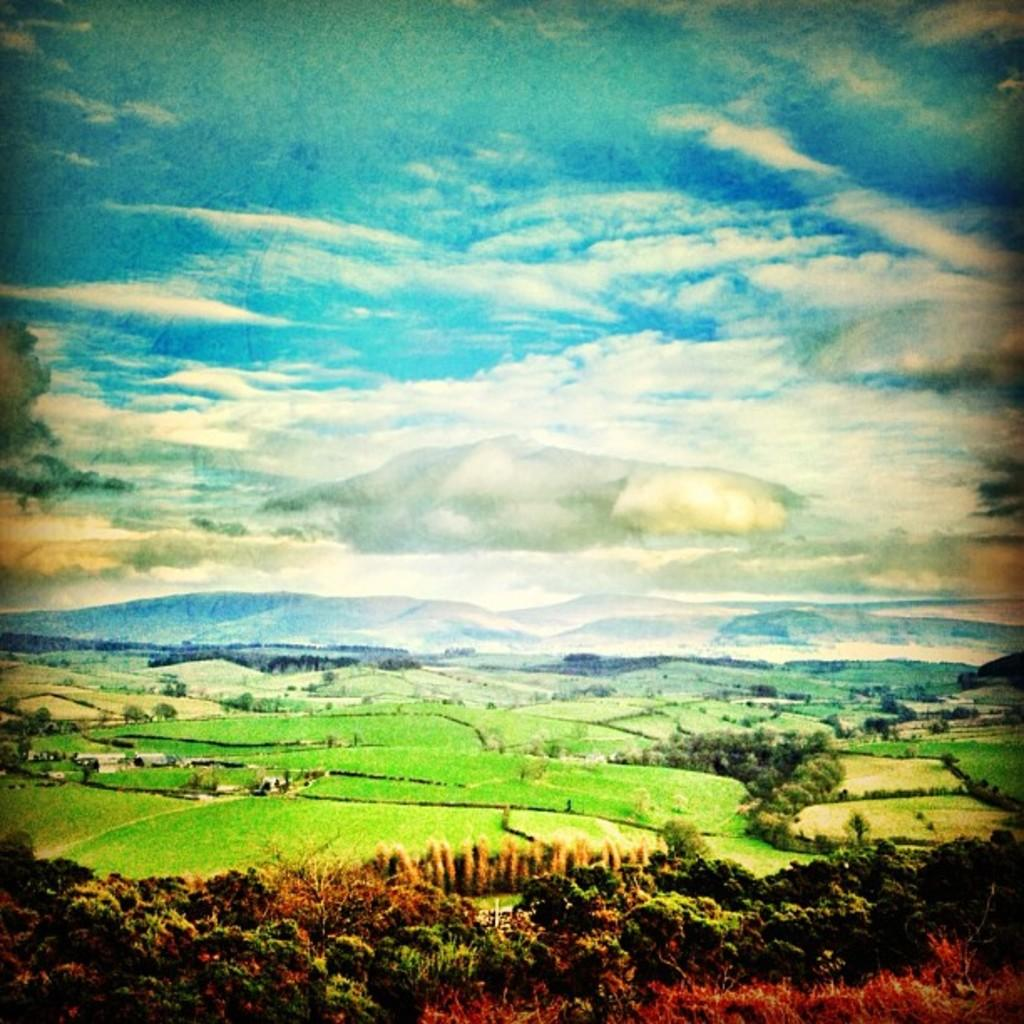What type of vegetation is at the bottom of the image? There are trees at the bottom of the image. What type of terrain is visible in the image? There is a grassy land in the image. What geographical feature can be seen in the background of the image? There are mountains in the background of the image. What is visible at the top of the image? The sky is visible at the top of the image. What is the weather like in the image? The sky appears to be cloudy in the image. How many sisters are wearing suits in the image? There are no sisters or suits present in the image. What type of trip can be seen in the image? There is no trip visible in the image; it features trees, grassy land, mountains, and a cloudy sky. 